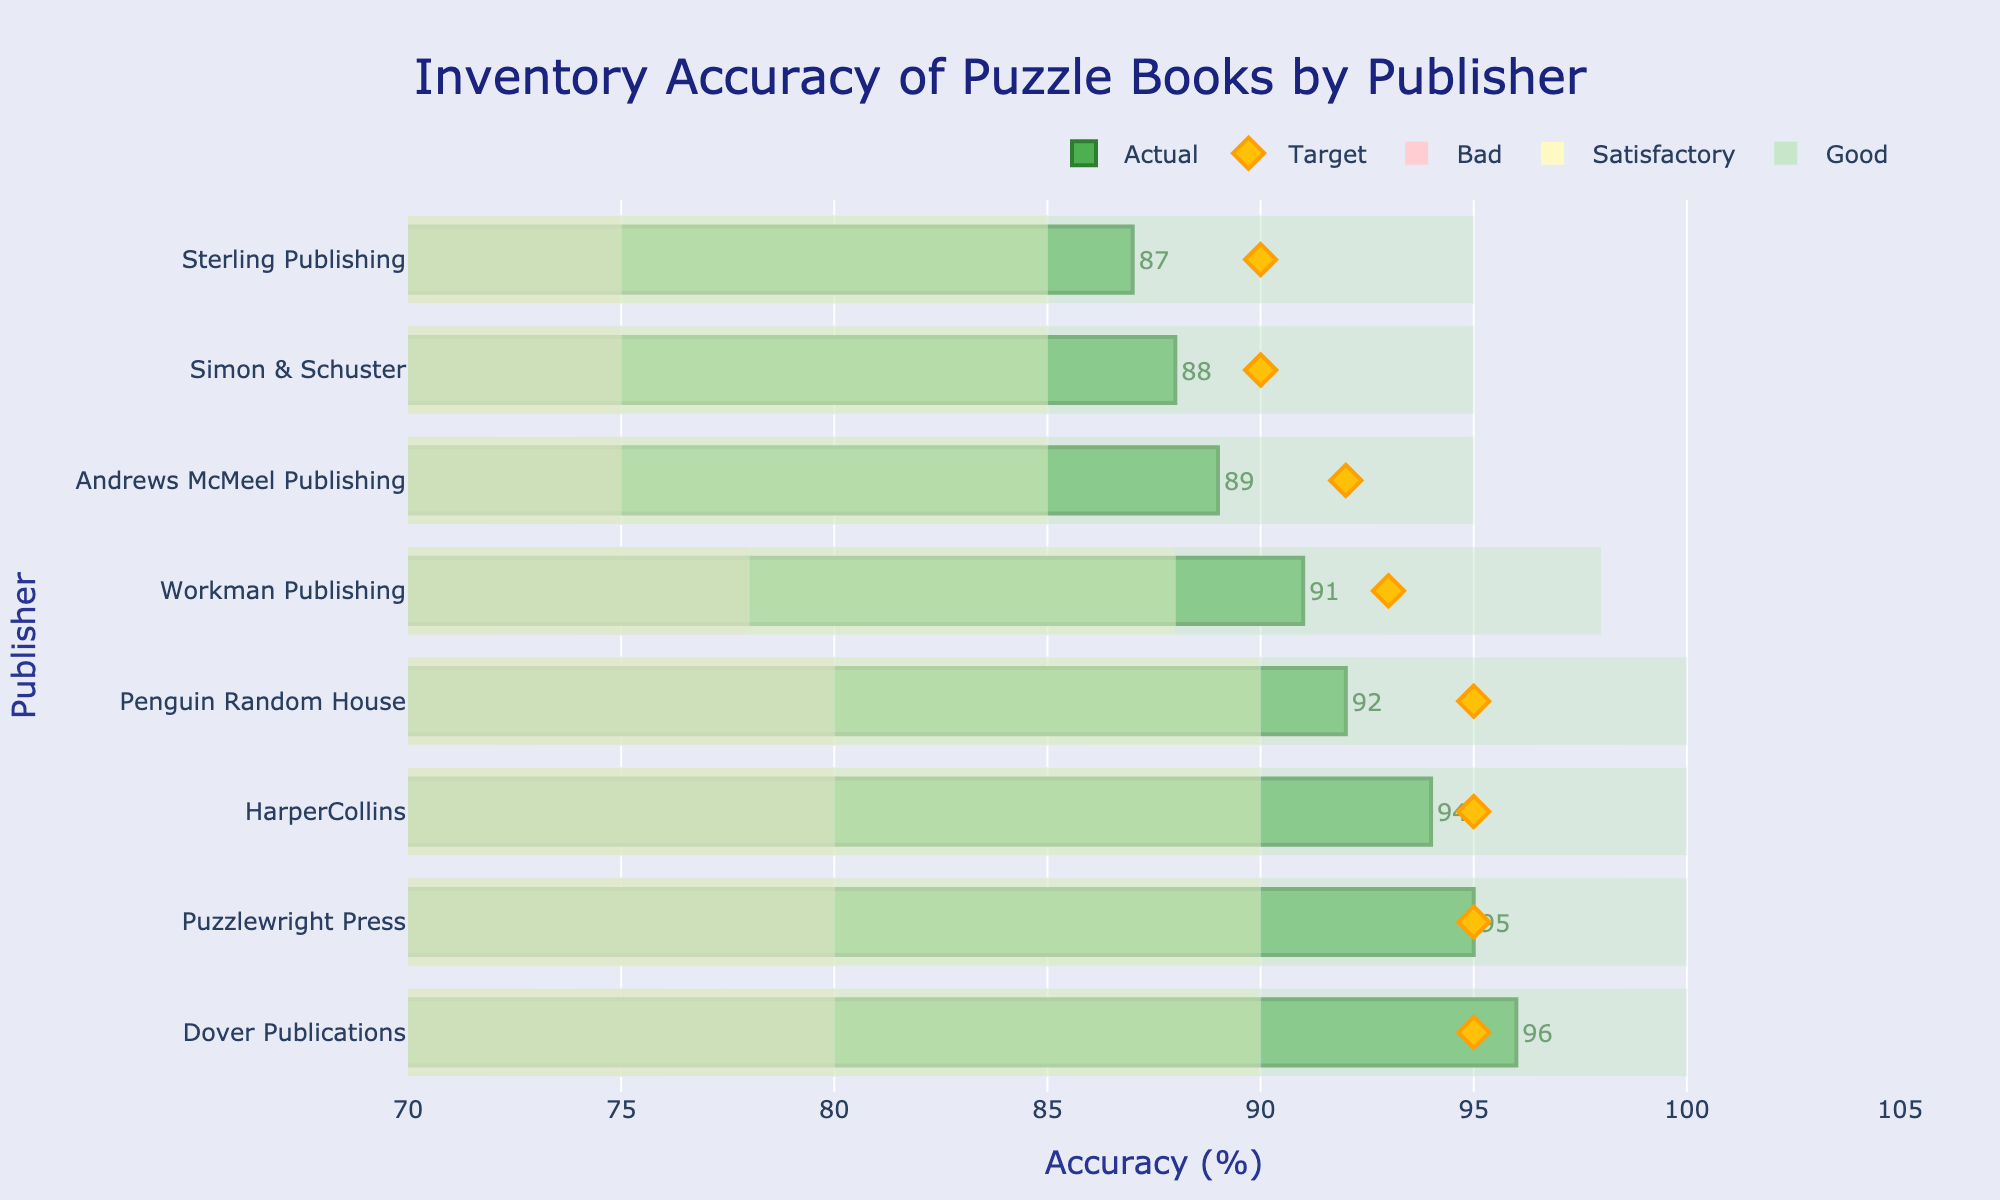What is the title of the figure? The title is usually found at the top of the chart and provides a summary of what the chart is about. In this case, it's mentioned under the `title` parameter in the `update_layout` function.
Answer: Inventory Accuracy of Puzzle Books by Publisher Which publisher has the highest actual inventory accuracy? By looking at the x-axis values and the bars, the publisher with the highest actual inventory accuracy is the one whose bar extends the farthest to the right. Here, Dover Publications has the highest value.
Answer: Dover Publications How many publishers have an actual inventory accuracy below their target? Compare the actual values and target markers for each publisher to count how many actual values are less than their corresponding targets. Here, Simon & Schuster, Andrews McMeel Publishing, and Sterling Publishing have actual values below their targets.
Answer: 3 What is the actual inventory accuracy of HarperCollins? Locate the bar corresponding to HarperCollins and read its value. It is also written outside the bar as a label.
Answer: 94% Around which value do most of the 'Good' ranges start? The 'Good' range is visually indicated by the greenish background in the figure. The majority of these ranges start around 90%.
Answer: 90% Which publishers achieved or exceeded their target inventory accuracy? Compare the actual values with the target markers. Those with equal or higher actual values than their targets are Penguin Random House, HarperCollins, Dover Publications, and Puzzlewright Press.
Answer: Penguin Random House, HarperCollins, Dover Publications, Puzzlewright Press How does the actual inventory accuracy of Workman Publishing compare to that of Sterling Publishing? Locate the bars for both Workman Publishing and Sterling Publishing and compare their lengths. Workman Publishing has an actual accuracy of 91%, while Sterling Publishing has 87%.
Answer: Workman Publishing has a higher accuracy than Sterling Publishing What is the average target inventory accuracy across all publishers? Sum up all the target values and divide by the number of publishers. (95+90+95+95+92+93+90+95) / 8 = 93.125.
Answer: 93.125% Which publisher falls in the 'Bad' range for their actual inventory accuracy? Identify bars falling in the pinkish-red colored 'Bad' range. Here, none of the publishers fall into the 'Bad' range since all actual values exceed the bad threshold.
Answer: None By how many percentage points does the actual inventory accuracy of Simon & Schuster fall short of its target? Subtract the actual value from the target value for Simon & Schuster. 90 - 88 = 2 percentage points.
Answer: 2 percentage points 